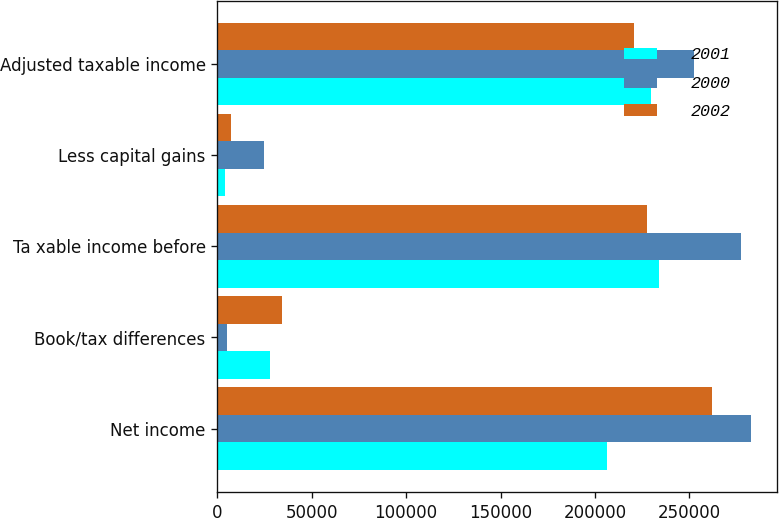Convert chart to OTSL. <chart><loc_0><loc_0><loc_500><loc_500><stacked_bar_chart><ecel><fcel>Net income<fcel>Book/tax differences<fcel>Ta xable income before<fcel>Less capital gains<fcel>Adjusted taxable income<nl><fcel>2001<fcel>206325<fcel>27698<fcel>234023<fcel>4203<fcel>229820<nl><fcel>2000<fcel>282409<fcel>4994<fcel>277415<fcel>24850<fcel>252565<nl><fcel>2002<fcel>261939<fcel>34182<fcel>227757<fcel>6975<fcel>220782<nl></chart> 